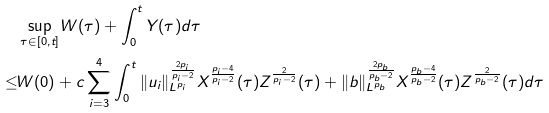<formula> <loc_0><loc_0><loc_500><loc_500>& \sup _ { \tau \in [ 0 , t ] } W ( \tau ) + \int _ { 0 } ^ { t } Y ( \tau ) d \tau \\ \leq & W ( 0 ) + c \sum _ { i = 3 } ^ { 4 } \int _ { 0 } ^ { t } \| u _ { i } \| _ { L ^ { p _ { i } } } ^ { \frac { 2 p _ { i } } { p _ { i } - 2 } } X ^ { \frac { p _ { i } - 4 } { p _ { i } - 2 } } ( \tau ) Z ^ { \frac { 2 } { p _ { i } - 2 } } ( \tau ) + \| b \| _ { L ^ { p _ { b } } } ^ { \frac { 2 p _ { b } } { p _ { b } - 2 } } X ^ { \frac { p _ { b } - 4 } { p _ { b } - 2 } } ( \tau ) Z ^ { \frac { 2 } { p _ { b } - 2 } } ( \tau ) d \tau</formula> 